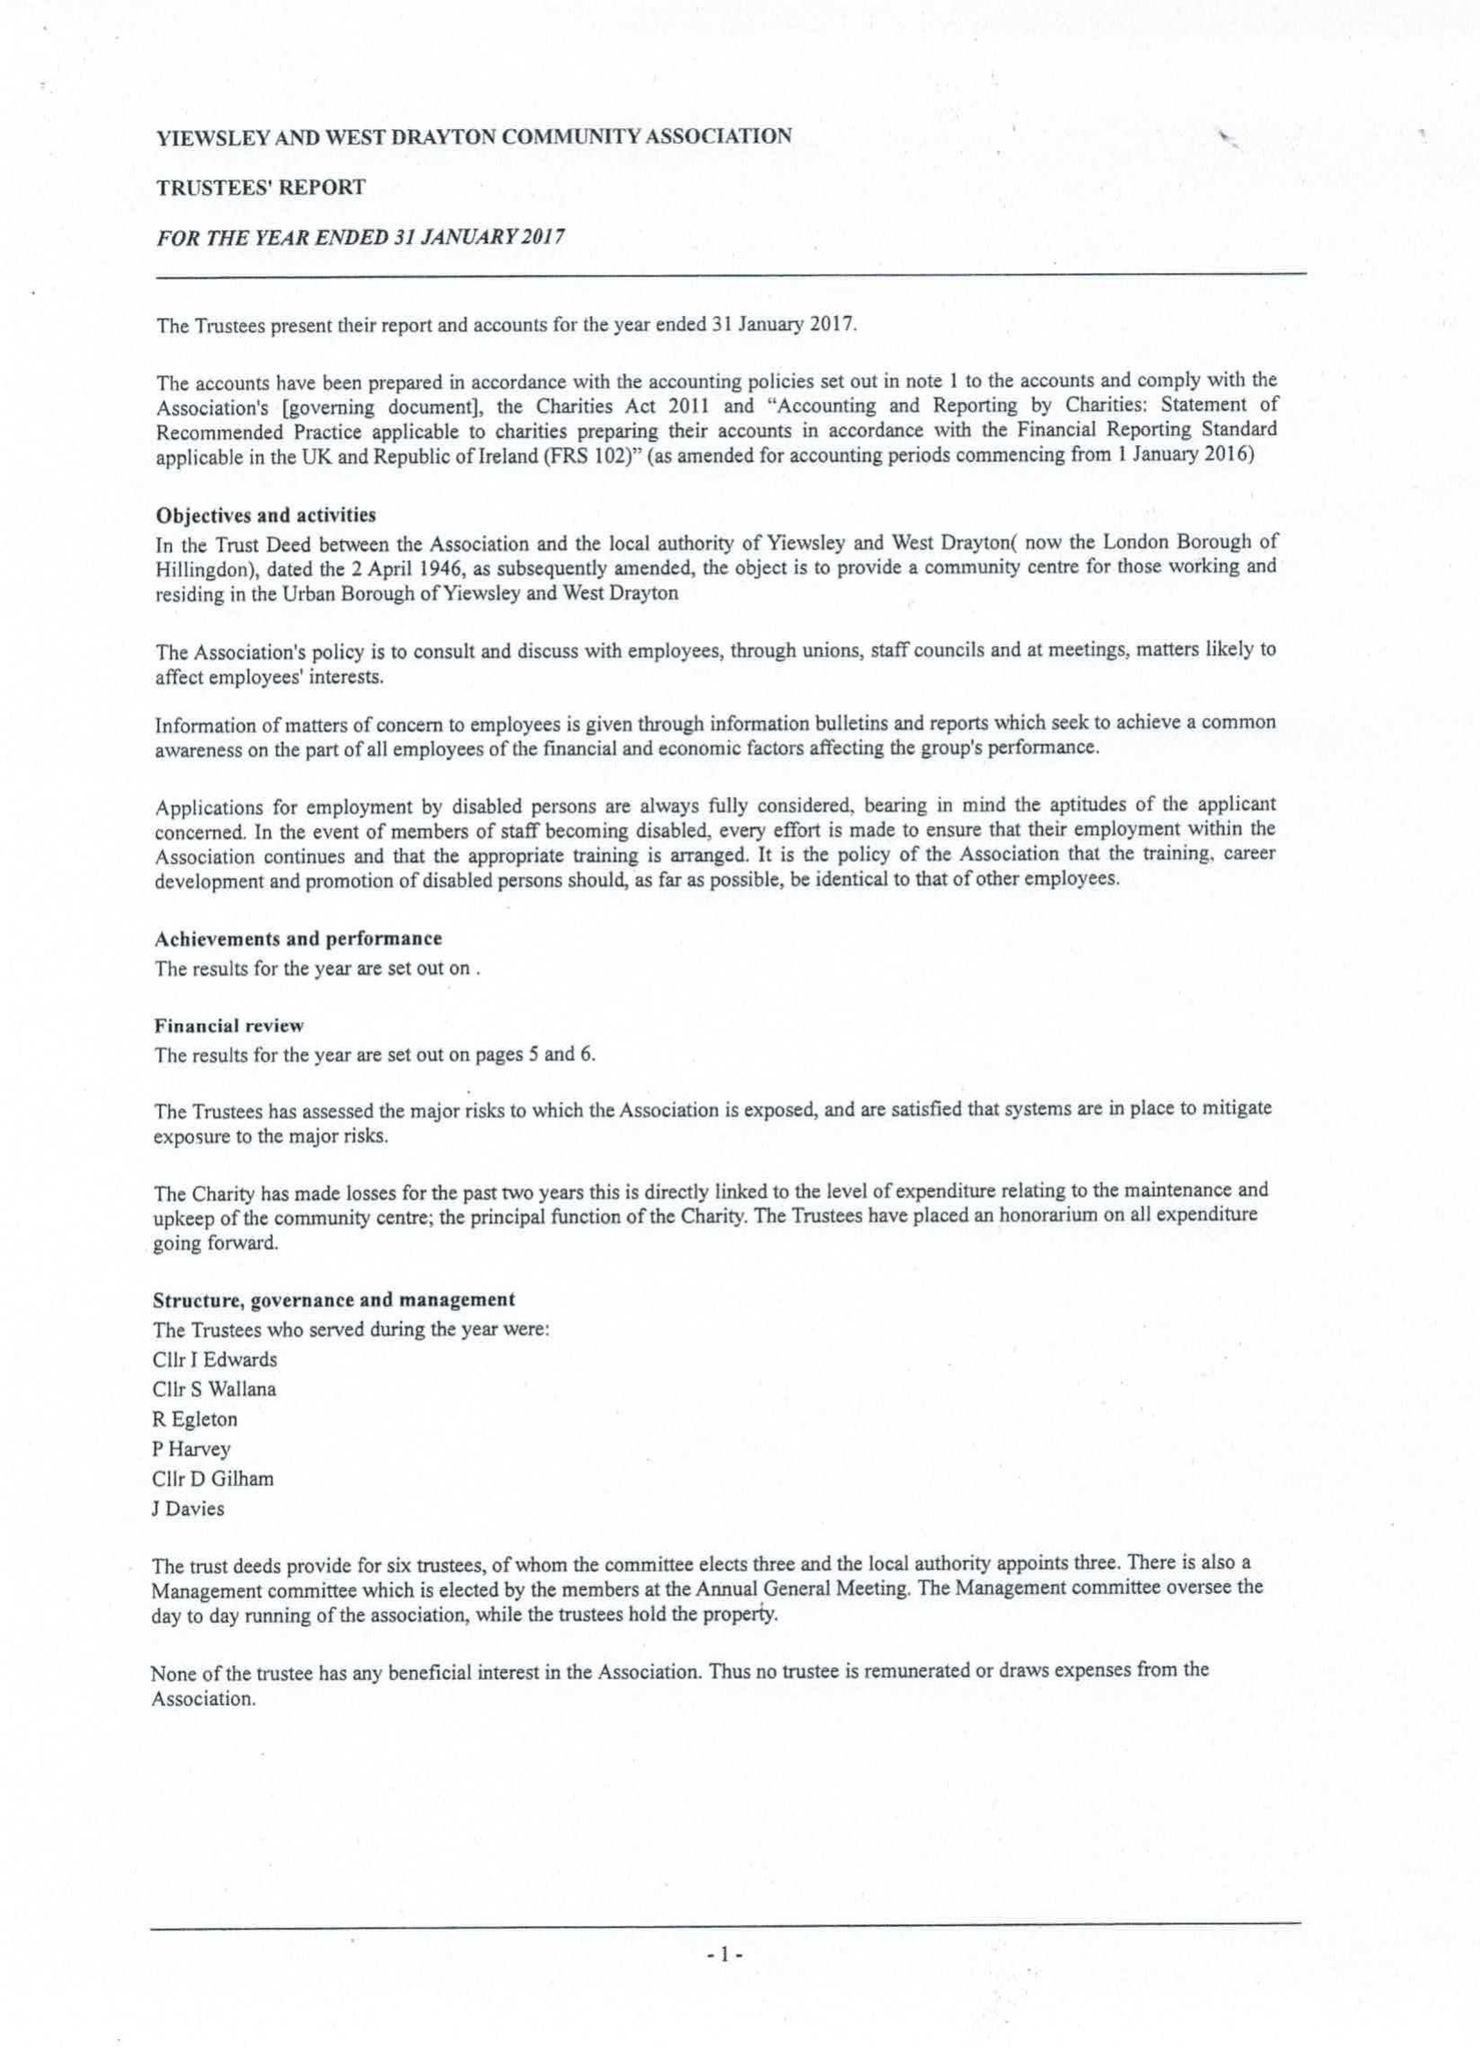What is the value for the address__street_line?
Answer the question using a single word or phrase. HARMONDSWORTH ROAD 